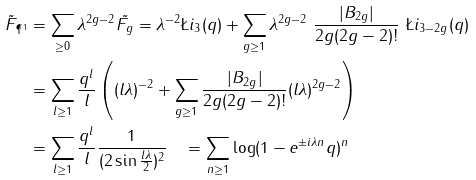<formula> <loc_0><loc_0><loc_500><loc_500>\tilde { F } _ { \P ^ { 1 } } & = \sum _ { \geq 0 } \lambda ^ { 2 g - 2 } \tilde { F _ { g } } = \lambda ^ { - 2 } \L i _ { 3 } ( q ) + \sum _ { g \geq 1 } \lambda ^ { 2 g - 2 } \ \frac { | B _ { 2 g } | } { 2 g ( 2 g - 2 ) ! } \ \L i _ { 3 - 2 g } ( q ) \\ & = \sum _ { l \geq 1 } \frac { q ^ { l } } { l } \left ( ( l \lambda ) ^ { - 2 } + \sum _ { g \geq 1 } \frac { | B _ { 2 g } | } { 2 g ( 2 g - 2 ) ! } ( l \lambda ) ^ { 2 g - 2 } \right ) \\ & = \sum _ { l \geq 1 } \frac { q ^ { l } } { l } \frac { 1 } { ( 2 \sin \frac { l \lambda } { 2 } ) ^ { 2 } } \quad = \sum _ { n \geq 1 } \log ( 1 - e ^ { \pm i \lambda n } q ) ^ { n }</formula> 